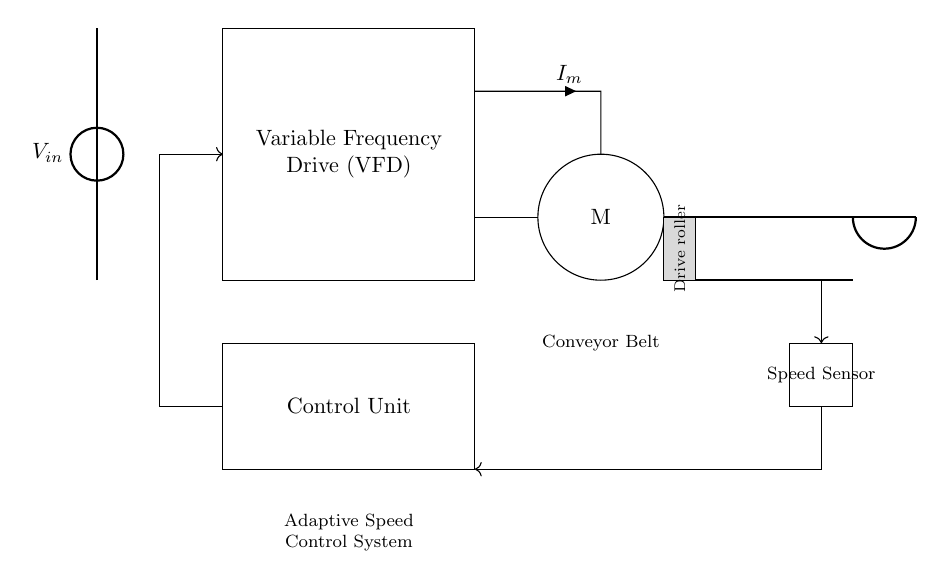What component is used to control the motor speed? The motor speed is controlled by a Variable Frequency Drive (VFD), which is represented as a rectangle in the circuit diagram. This component adjusts the frequency and voltage of the power supplied to the motor, enabling speed control.
Answer: Variable Frequency Drive What does the speed sensor do in this system? The speed sensor measures the actual speed of the conveyor belt and provides feedback to the control unit, ensuring that the system can adapt the motor speed as needed. This feedback loop is an essential feature of adaptive systems.
Answer: Measures speed How many main components are in the circuit diagram? The main components in the diagram are the Variable Frequency Drive, Motor, Conveyor Belt, Speed Sensor, and Control Unit. Counting each of these distinct parts results in a total of five components.
Answer: Five What type of control strategy is implemented in this circuit? The circuit implements an adaptive control strategy, wherein the control unit continuously receives feedback from the speed sensor and adjusts the motor speed via the Variable Frequency Drive to match the desired output.
Answer: Adaptive control Which component is essential for motor operation in this system? The essential component for motor operation is the Variable Frequency Drive (VFD). It regulates the electrical power, making it possible for the motor to operate at varying speeds. Without it, the motor would not perform effectively across different load conditions.
Answer: Variable Frequency Drive What is the purpose of the feedback loop in the circuit? The feedback loop connects the speed sensor to the control unit. Its purpose is to allow the control unit to adjust the motor drive based on the real-time information provided by the speed sensor, ensuring optimal performance of the conveyor system.
Answer: To adjust motor speed 